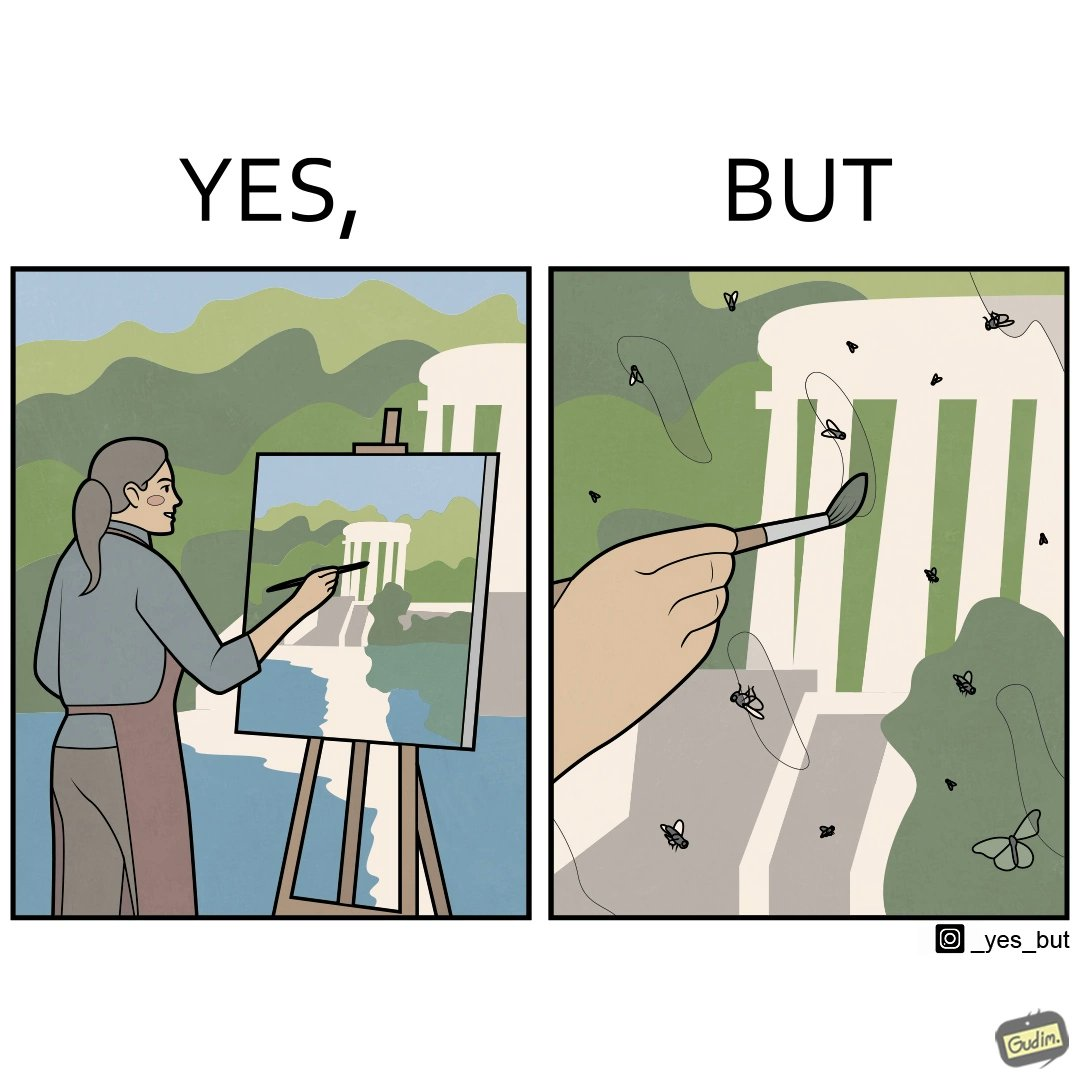Is this a satirical image? Yes, this image is satirical. 